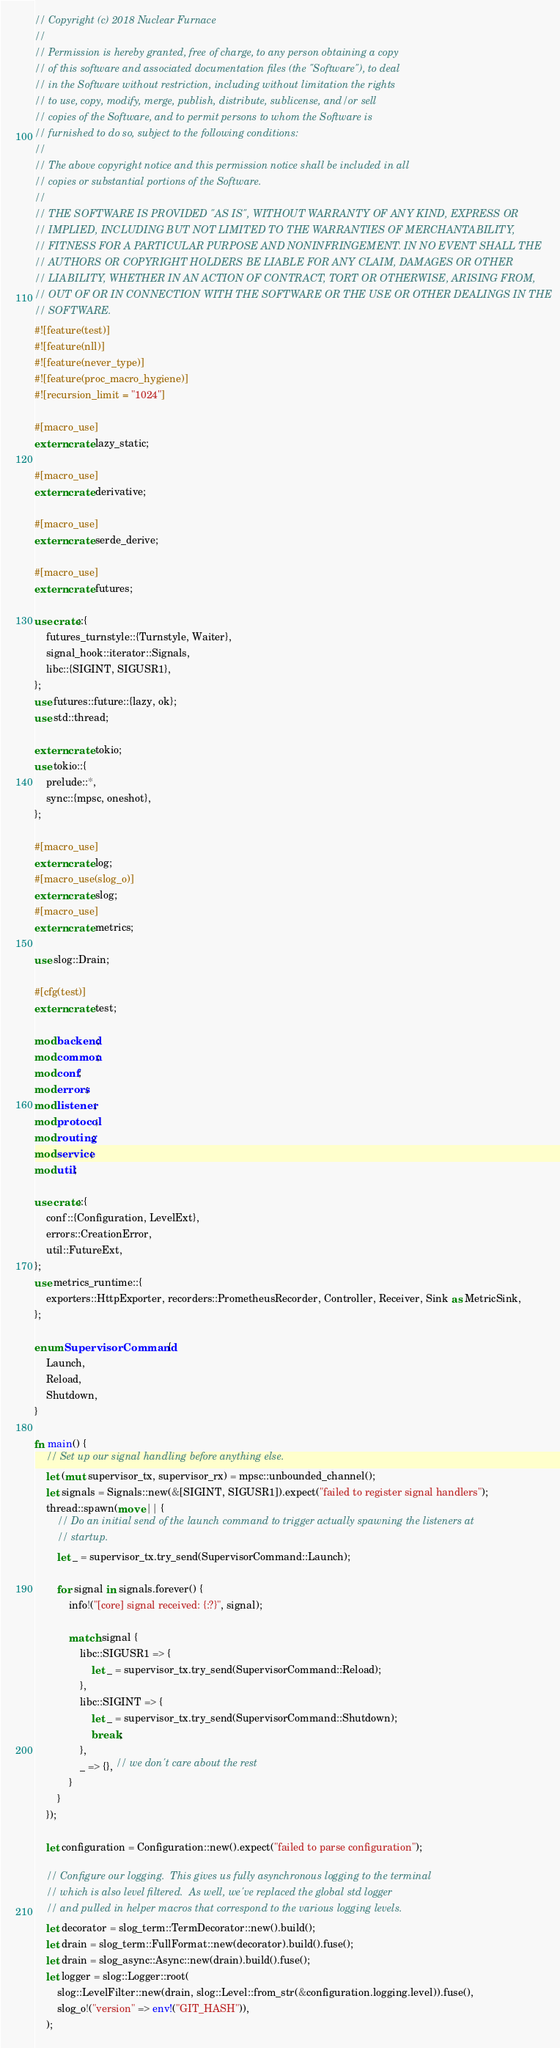Convert code to text. <code><loc_0><loc_0><loc_500><loc_500><_Rust_>// Copyright (c) 2018 Nuclear Furnace
//
// Permission is hereby granted, free of charge, to any person obtaining a copy
// of this software and associated documentation files (the "Software"), to deal
// in the Software without restriction, including without limitation the rights
// to use, copy, modify, merge, publish, distribute, sublicense, and/or sell
// copies of the Software, and to permit persons to whom the Software is
// furnished to do so, subject to the following conditions:
//
// The above copyright notice and this permission notice shall be included in all
// copies or substantial portions of the Software.
//
// THE SOFTWARE IS PROVIDED "AS IS", WITHOUT WARRANTY OF ANY KIND, EXPRESS OR
// IMPLIED, INCLUDING BUT NOT LIMITED TO THE WARRANTIES OF MERCHANTABILITY,
// FITNESS FOR A PARTICULAR PURPOSE AND NONINFRINGEMENT. IN NO EVENT SHALL THE
// AUTHORS OR COPYRIGHT HOLDERS BE LIABLE FOR ANY CLAIM, DAMAGES OR OTHER
// LIABILITY, WHETHER IN AN ACTION OF CONTRACT, TORT OR OTHERWISE, ARISING FROM,
// OUT OF OR IN CONNECTION WITH THE SOFTWARE OR THE USE OR OTHER DEALINGS IN THE
// SOFTWARE.
#![feature(test)]
#![feature(nll)]
#![feature(never_type)]
#![feature(proc_macro_hygiene)]
#![recursion_limit = "1024"]

#[macro_use]
extern crate lazy_static;

#[macro_use]
extern crate derivative;

#[macro_use]
extern crate serde_derive;

#[macro_use]
extern crate futures;

use crate::{
    futures_turnstyle::{Turnstyle, Waiter},
    signal_hook::iterator::Signals,
    libc::{SIGINT, SIGUSR1},
};
use futures::future::{lazy, ok};
use std::thread;

extern crate tokio;
use tokio::{
    prelude::*,
    sync::{mpsc, oneshot},
};

#[macro_use]
extern crate log;
#[macro_use(slog_o)]
extern crate slog;
#[macro_use]
extern crate metrics;

use slog::Drain;

#[cfg(test)]
extern crate test;

mod backend;
mod common;
mod conf;
mod errors;
mod listener;
mod protocol;
mod routing;
mod service;
mod util;

use crate::{
    conf::{Configuration, LevelExt},
    errors::CreationError,
    util::FutureExt,
};
use metrics_runtime::{
    exporters::HttpExporter, recorders::PrometheusRecorder, Controller, Receiver, Sink as MetricSink,
};

enum SupervisorCommand {
    Launch,
    Reload,
    Shutdown,
}

fn main() {
    // Set up our signal handling before anything else.
    let (mut supervisor_tx, supervisor_rx) = mpsc::unbounded_channel();
    let signals = Signals::new(&[SIGINT, SIGUSR1]).expect("failed to register signal handlers");
    thread::spawn(move || {
        // Do an initial send of the launch command to trigger actually spawning the listeners at
        // startup.
        let _ = supervisor_tx.try_send(SupervisorCommand::Launch);

        for signal in signals.forever() {
            info!("[core] signal received: {:?}", signal);

            match signal {
                libc::SIGUSR1 => {
                    let _ = supervisor_tx.try_send(SupervisorCommand::Reload);
                },
                libc::SIGINT => {
                    let _ = supervisor_tx.try_send(SupervisorCommand::Shutdown);
                    break;
                },
                _ => {}, // we don't care about the rest
            }
        }
    });

    let configuration = Configuration::new().expect("failed to parse configuration");

    // Configure our logging.  This gives us fully asynchronous logging to the terminal
    // which is also level filtered.  As well, we've replaced the global std logger
    // and pulled in helper macros that correspond to the various logging levels.
    let decorator = slog_term::TermDecorator::new().build();
    let drain = slog_term::FullFormat::new(decorator).build().fuse();
    let drain = slog_async::Async::new(drain).build().fuse();
    let logger = slog::Logger::root(
        slog::LevelFilter::new(drain, slog::Level::from_str(&configuration.logging.level)).fuse(),
        slog_o!("version" => env!("GIT_HASH")),
    );
</code> 